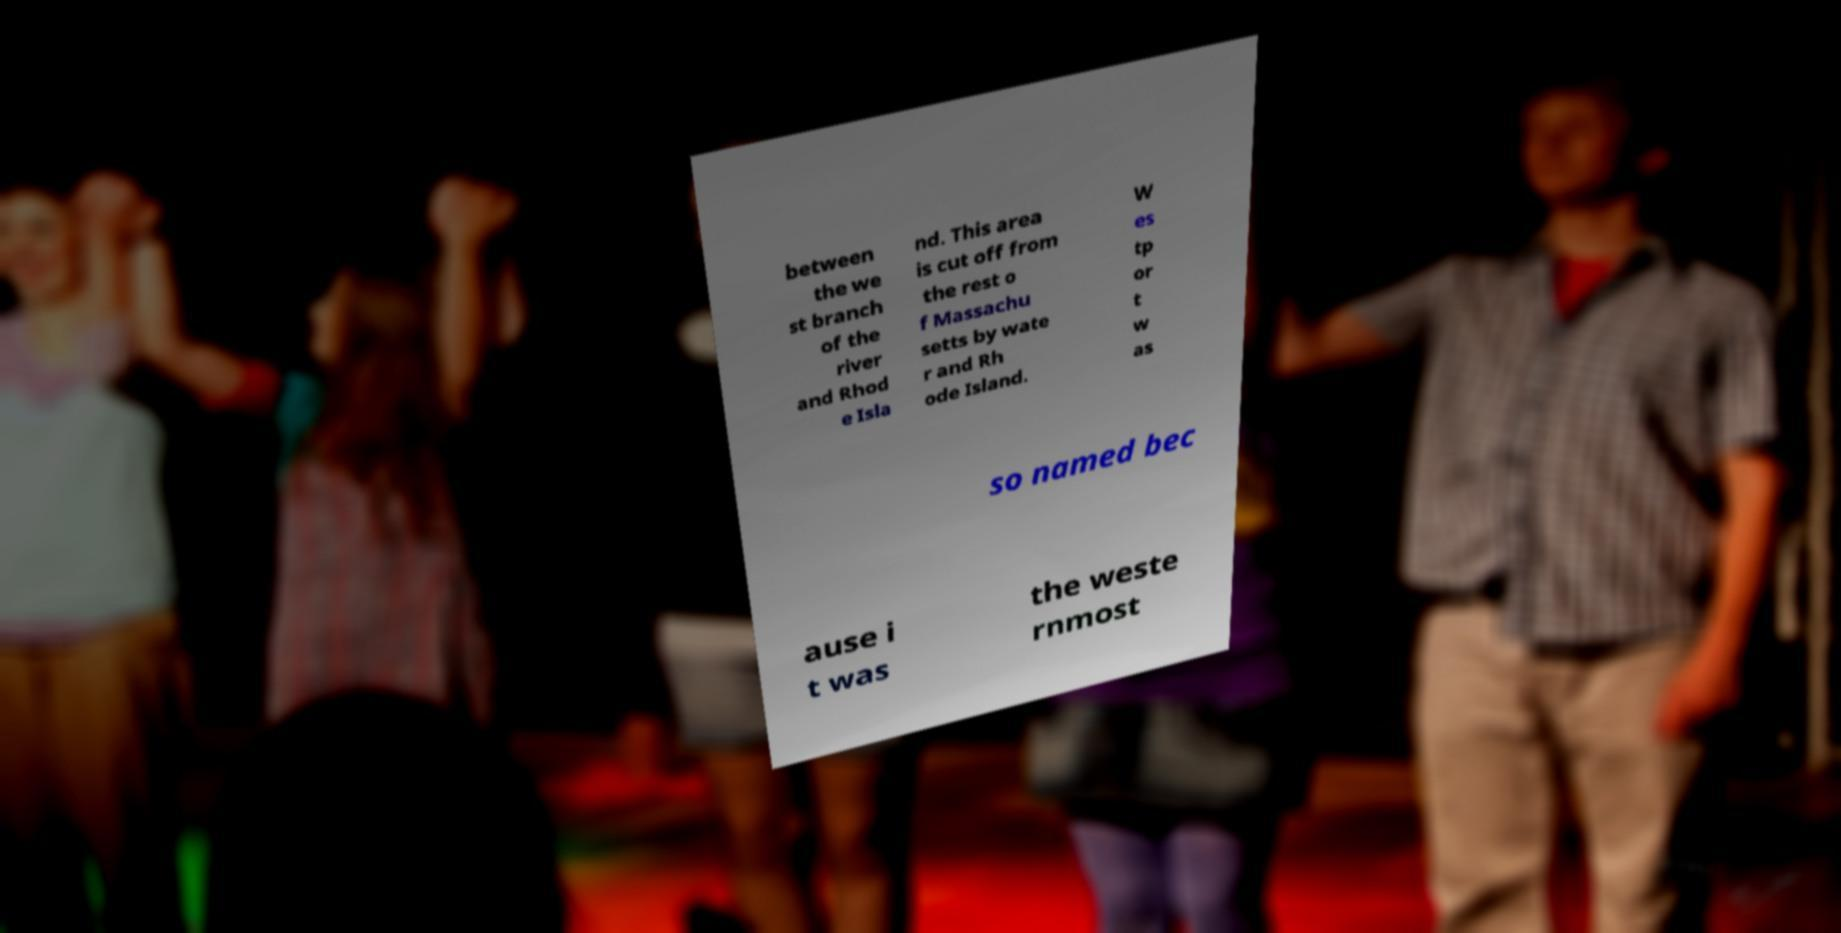Can you read and provide the text displayed in the image?This photo seems to have some interesting text. Can you extract and type it out for me? between the we st branch of the river and Rhod e Isla nd. This area is cut off from the rest o f Massachu setts by wate r and Rh ode Island. W es tp or t w as so named bec ause i t was the weste rnmost 